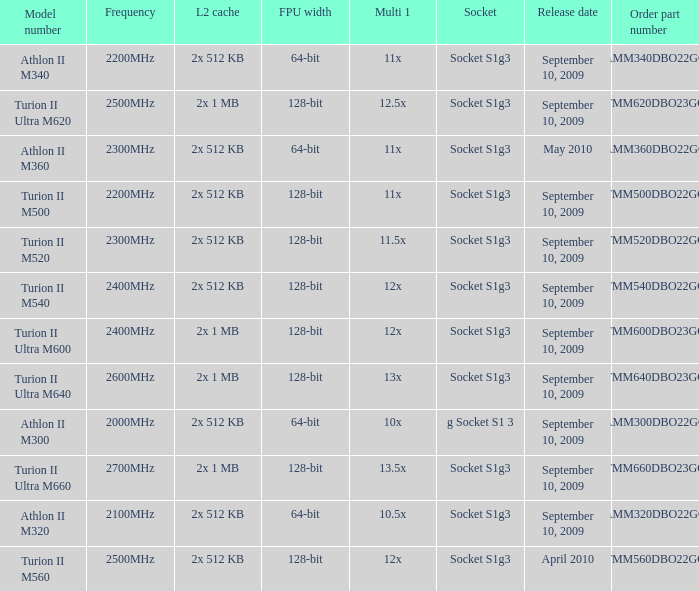What is the frequency of the tmm500dbo22gq order part number? 2200MHz. 